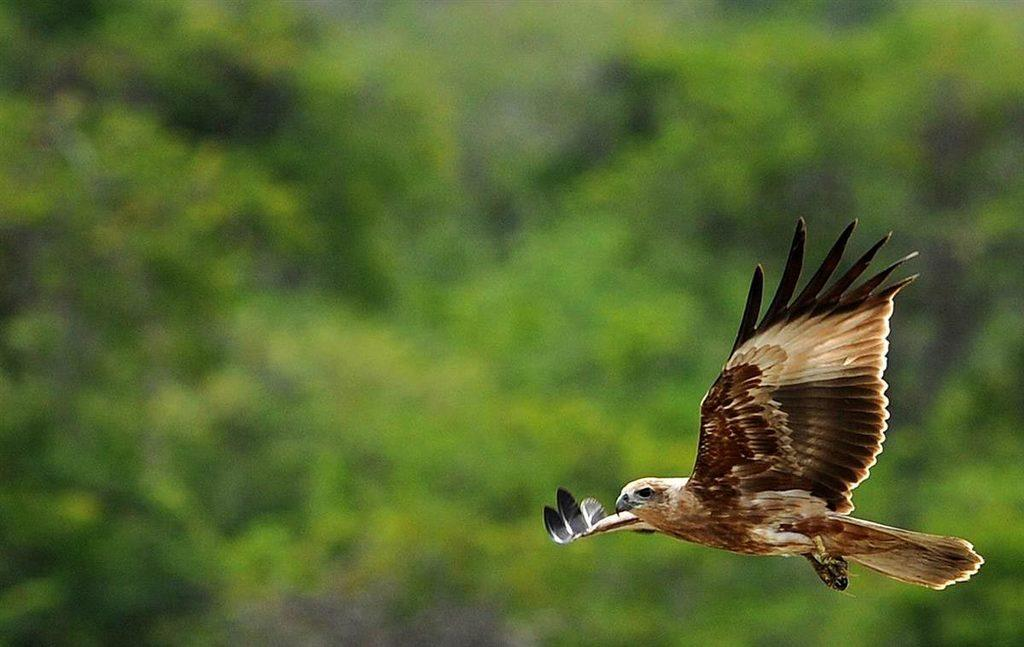What animal is the main subject of the picture? There is an eagle in the picture. What is the eagle doing in the image? The eagle is flying. Can you describe the background of the image? The background of the image is blurry. How many brothers does the grandfather have in the image? There is no grandfather or brothers present in the image; it features an eagle flying in a blurry background. What type of dock can be seen in the image? There is no dock present in the image; it features an eagle flying in a blurry background. 